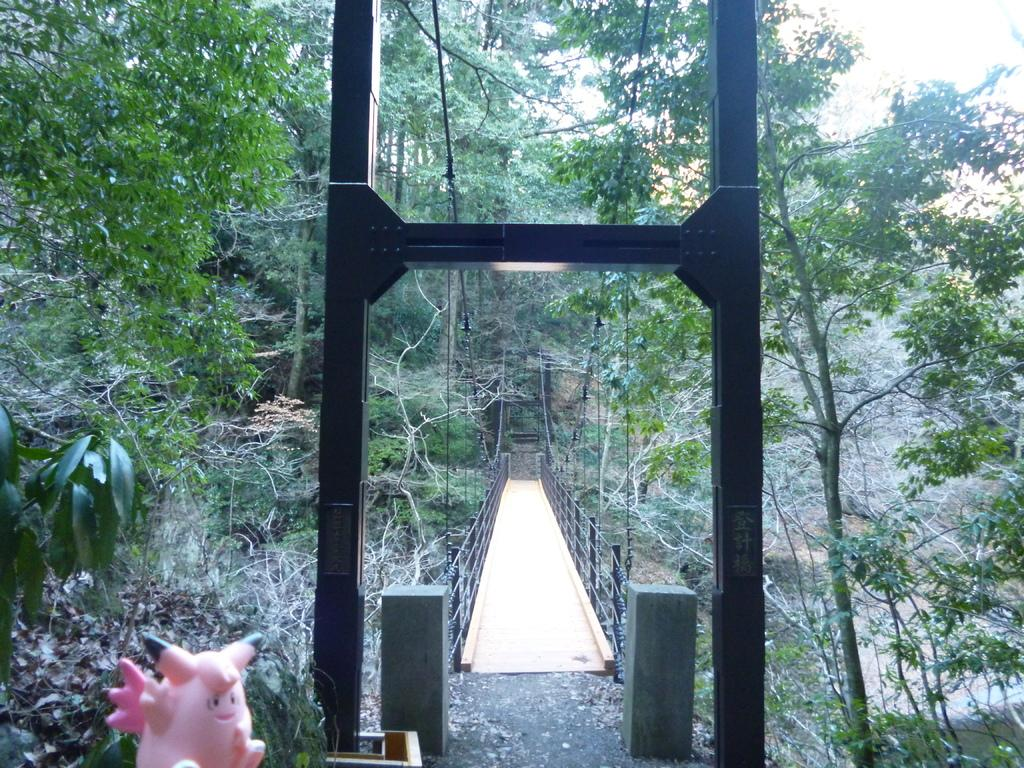What is located on the left side of the image? There is a doll on the left side of the image. What can be seen in the background of the image? There is a bridge in the background of the image. What type of vegetation is present on both sides of the bridge? There are plants and trees on both sides of the bridge. What part of the natural environment is visible in the background of the image? The sky is visible in the background of the image. How does the doll help the bean grow in the image? There is no bean present in the image, and the doll is not interacting with any plants or trees. 